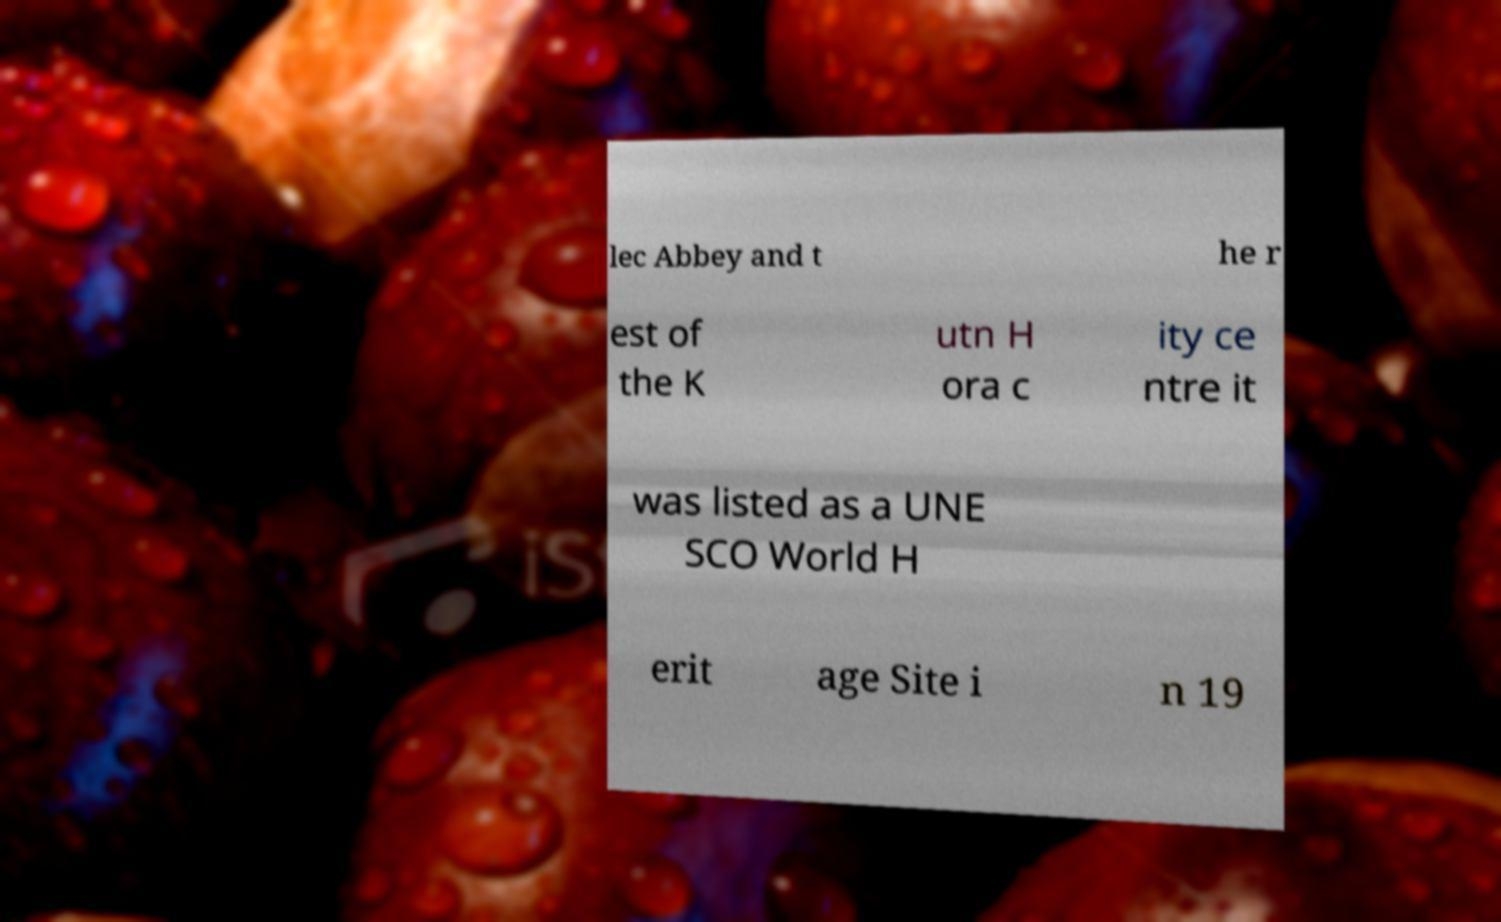I need the written content from this picture converted into text. Can you do that? lec Abbey and t he r est of the K utn H ora c ity ce ntre it was listed as a UNE SCO World H erit age Site i n 19 